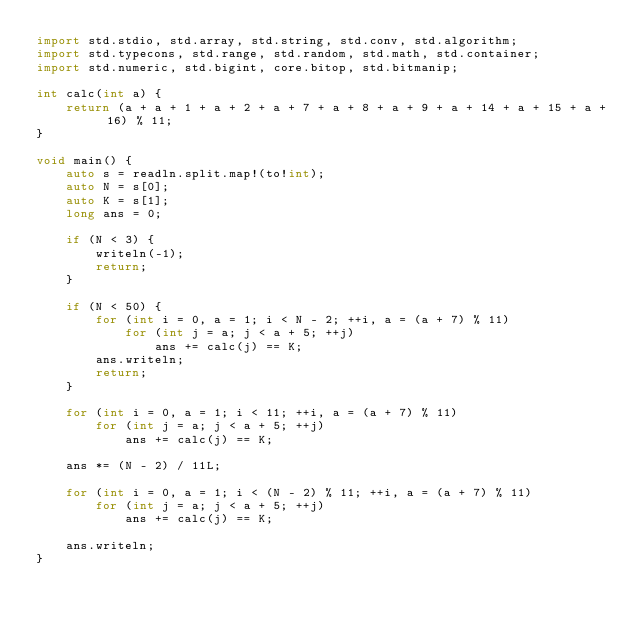Convert code to text. <code><loc_0><loc_0><loc_500><loc_500><_D_>import std.stdio, std.array, std.string, std.conv, std.algorithm;
import std.typecons, std.range, std.random, std.math, std.container;
import std.numeric, std.bigint, core.bitop, std.bitmanip;

int calc(int a) {
    return (a + a + 1 + a + 2 + a + 7 + a + 8 + a + 9 + a + 14 + a + 15 + a + 16) % 11;
}

void main() {
    auto s = readln.split.map!(to!int);
    auto N = s[0];
    auto K = s[1];
    long ans = 0;

    if (N < 3) {
        writeln(-1);
        return;
    }

    if (N < 50) {
        for (int i = 0, a = 1; i < N - 2; ++i, a = (a + 7) % 11) 
            for (int j = a; j < a + 5; ++j) 
                ans += calc(j) == K;
        ans.writeln;
        return;
    }

    for (int i = 0, a = 1; i < 11; ++i, a = (a + 7) % 11) 
        for (int j = a; j < a + 5; ++j) 
            ans += calc(j) == K;
    
    ans *= (N - 2) / 11L;

    for (int i = 0, a = 1; i < (N - 2) % 11; ++i, a = (a + 7) % 11) 
        for (int j = a; j < a + 5; ++j) 
            ans += calc(j) == K;

    ans.writeln;
}
</code> 